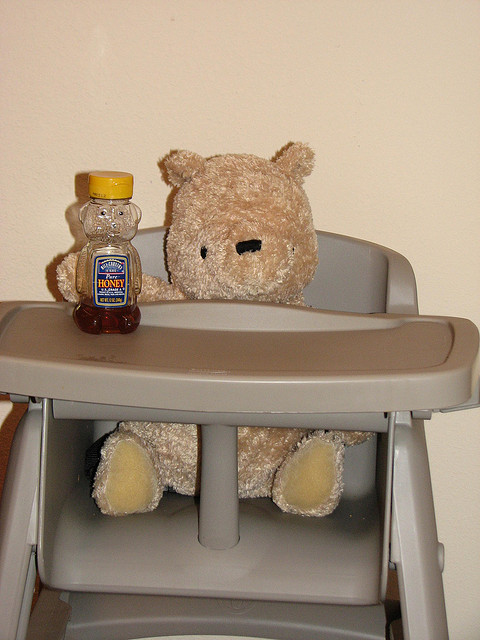Please identify all text content in this image. HONEY 